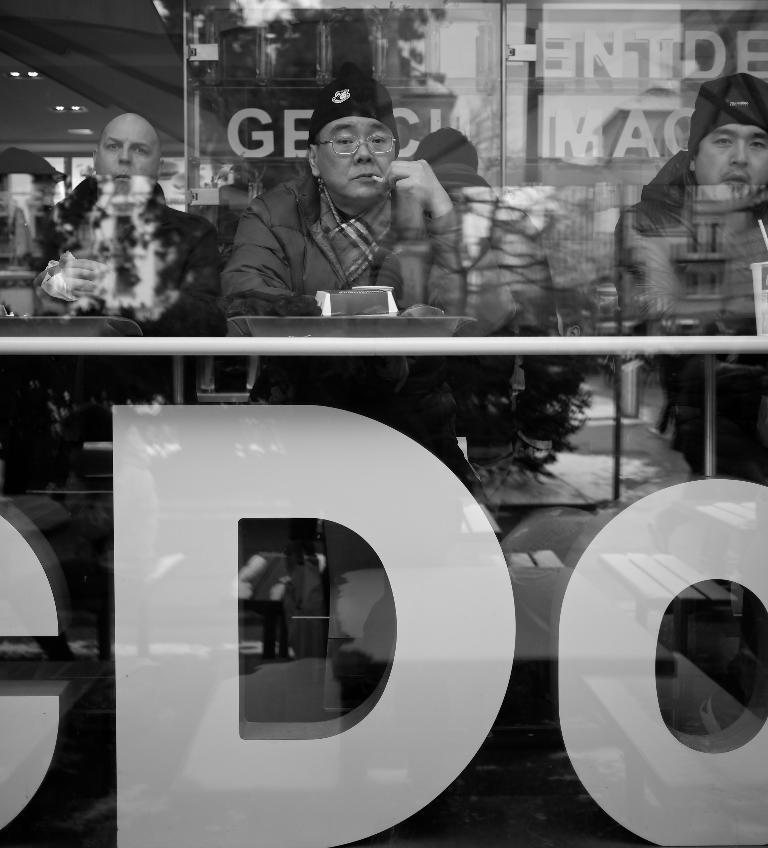How many people are in the image? There are three men in the image. What are the men doing in the image? The men are sitting in the image. What is in front of the men? There is a table in front of the men. What is on the table? There is a tray on the table, and a cup is on the tray. What is the queen's income in the image? There is no queen or mention of income in the image. 